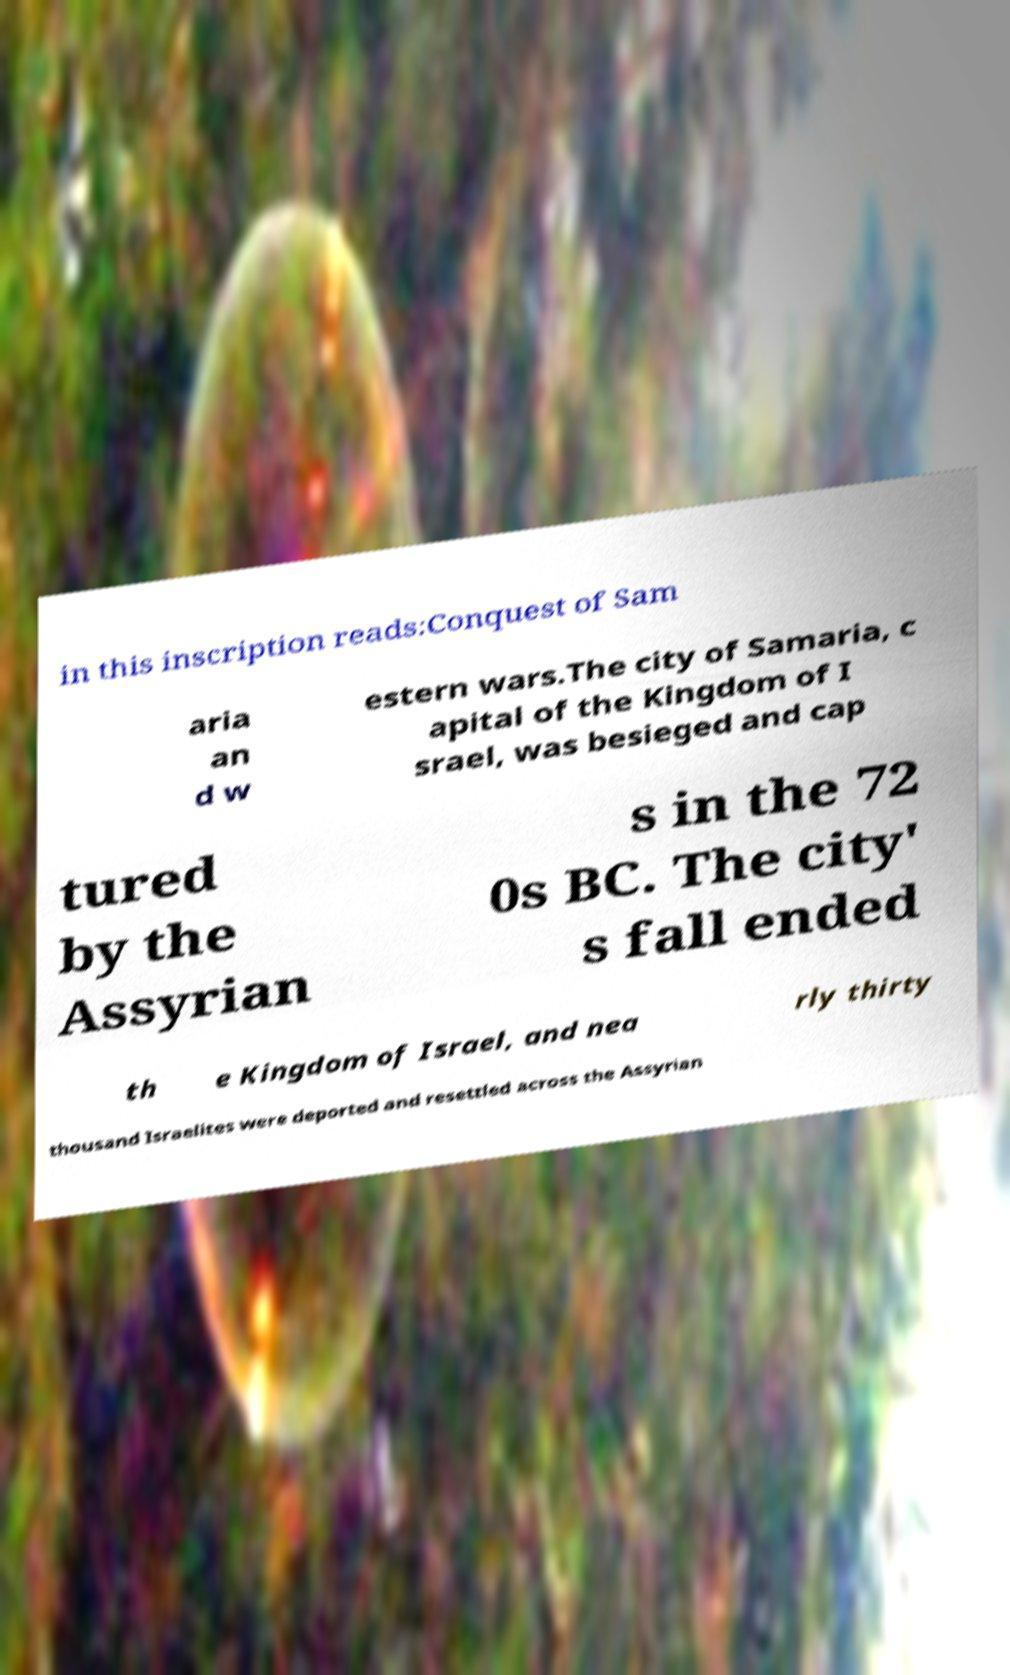For documentation purposes, I need the text within this image transcribed. Could you provide that? in this inscription reads:Conquest of Sam aria an d w estern wars.The city of Samaria, c apital of the Kingdom of I srael, was besieged and cap tured by the Assyrian s in the 72 0s BC. The city' s fall ended th e Kingdom of Israel, and nea rly thirty thousand Israelites were deported and resettled across the Assyrian 